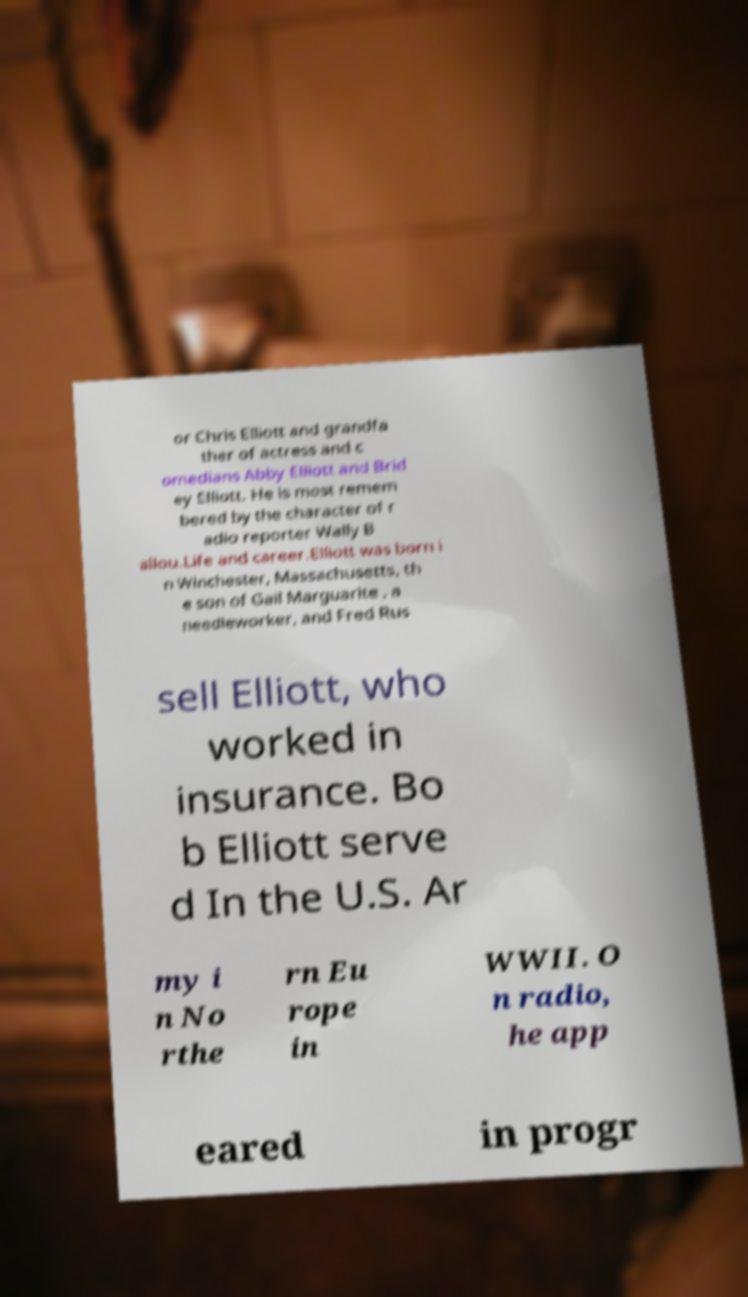Could you assist in decoding the text presented in this image and type it out clearly? or Chris Elliott and grandfa ther of actress and c omedians Abby Elliott and Brid ey Elliott. He is most remem bered by the character of r adio reporter Wally B allou.Life and career.Elliott was born i n Winchester, Massachusetts, th e son of Gail Marguarite , a needleworker, and Fred Rus sell Elliott, who worked in insurance. Bo b Elliott serve d In the U.S. Ar my i n No rthe rn Eu rope in WWII. O n radio, he app eared in progr 